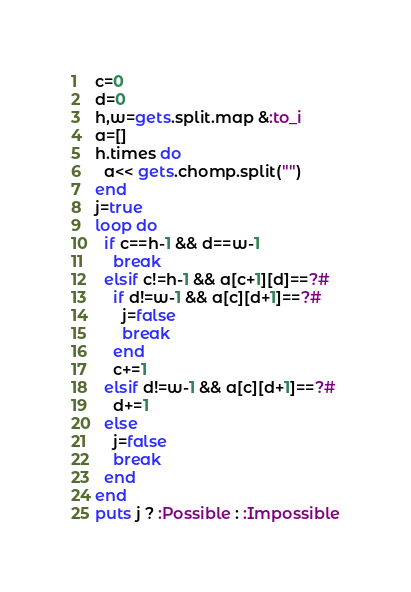Convert code to text. <code><loc_0><loc_0><loc_500><loc_500><_Ruby_>c=0
d=0
h,w=gets.split.map &:to_i
a=[]
h.times do
  a<< gets.chomp.split("")
end
j=true
loop do
  if c==h-1 && d==w-1
    break
  elsif c!=h-1 && a[c+1][d]==?#
    if d!=w-1 && a[c][d+1]==?#
      j=false
      break
    end
    c+=1
  elsif d!=w-1 && a[c][d+1]==?#
    d+=1
  else
    j=false
    break
  end
end
puts j ? :Possible : :Impossible</code> 